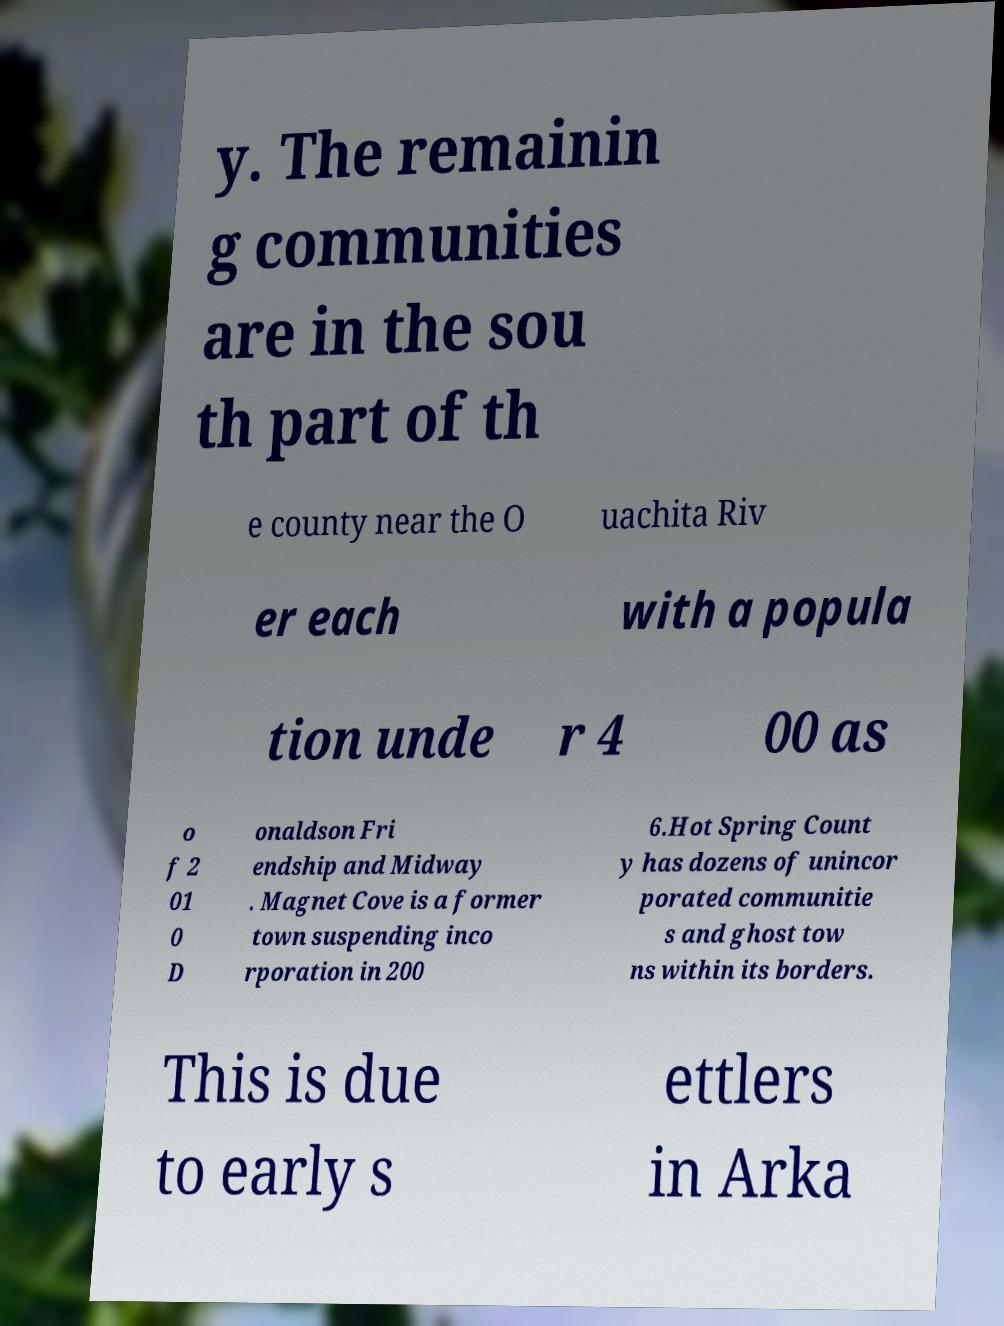For documentation purposes, I need the text within this image transcribed. Could you provide that? y. The remainin g communities are in the sou th part of th e county near the O uachita Riv er each with a popula tion unde r 4 00 as o f 2 01 0 D onaldson Fri endship and Midway . Magnet Cove is a former town suspending inco rporation in 200 6.Hot Spring Count y has dozens of unincor porated communitie s and ghost tow ns within its borders. This is due to early s ettlers in Arka 